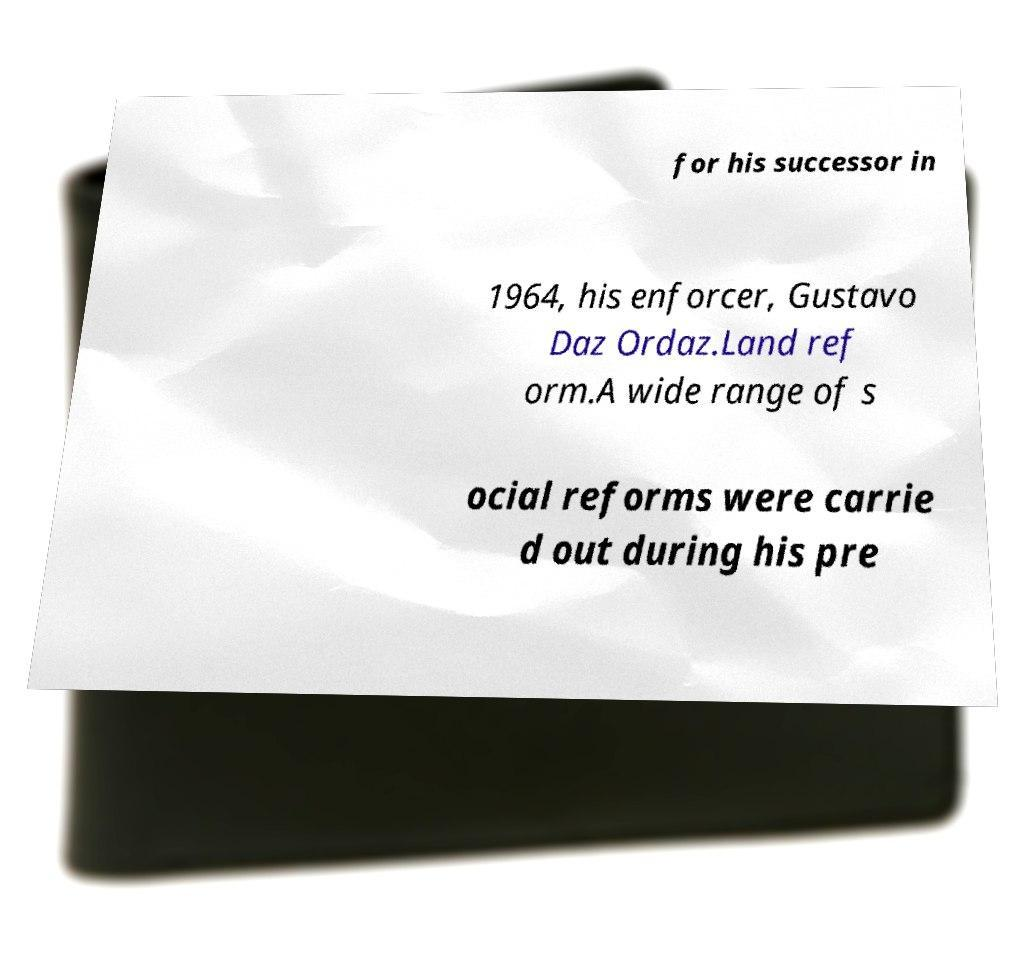There's text embedded in this image that I need extracted. Can you transcribe it verbatim? for his successor in 1964, his enforcer, Gustavo Daz Ordaz.Land ref orm.A wide range of s ocial reforms were carrie d out during his pre 